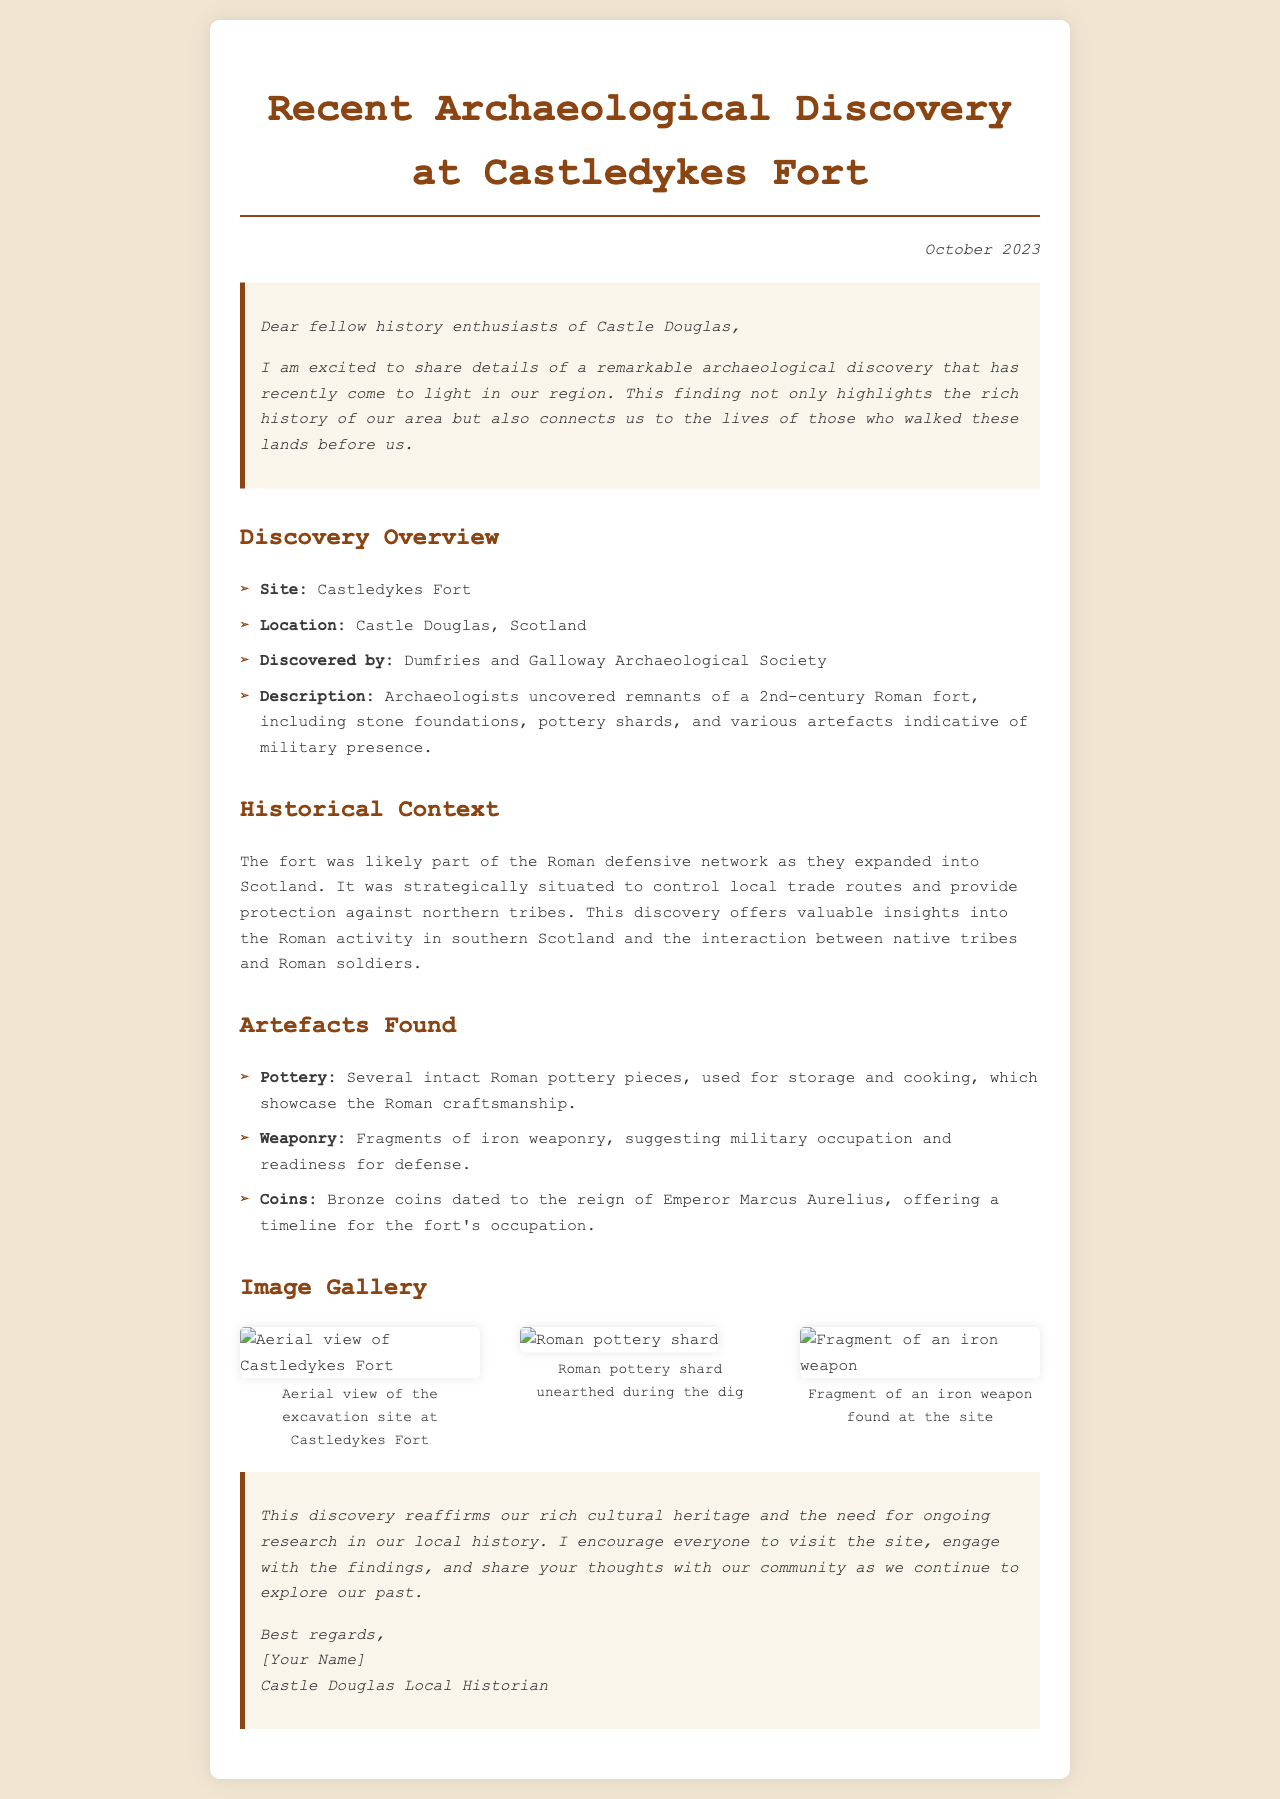What is the location of the discovered site? The site is specifically mentioned as Castle Douglas, Scotland in the document.
Answer: Castle Douglas Who discovered the archaeological site? The document attributes the discovery to the Dumfries and Galloway Archaeological Society.
Answer: Dumfries and Galloway Archaeological Society What century does the Roman fort date back to? The overview mentions that the fort dates back to the 2nd-century.
Answer: 2nd-century What was found that indicates a military presence? The document lists fragments of iron weaponry as evidence of military occupation.
Answer: Fragments of iron weaponry Which Emperor's reign do the found coins date to? The document specifies that the coins are dated to the reign of Emperor Marcus Aurelius.
Answer: Emperor Marcus Aurelius Why was the fort strategically important? The historical context explains that it controlled local trade routes and provided protection against northern tribes.
Answer: Controlled local trade routes and provided protection What type of artifacts were unearthed besides pottery? The document mentions weaponry and coins in addition to pottery.
Answer: Weaponry and coins What type of items does the image gallery feature? The image gallery consists of pictures related to the excavation and artifacts discovered.
Answer: Excavation and artifacts What is the overall purpose of sharing this discovery with the community? The conclusion emphasizes the importance of ongoing research and community engagement with local history.
Answer: Ongoing research and community engagement 